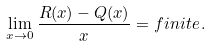Convert formula to latex. <formula><loc_0><loc_0><loc_500><loc_500>\lim _ { x \to 0 } \frac { R ( x ) - Q ( x ) } { x } = f i n i t e \, .</formula> 